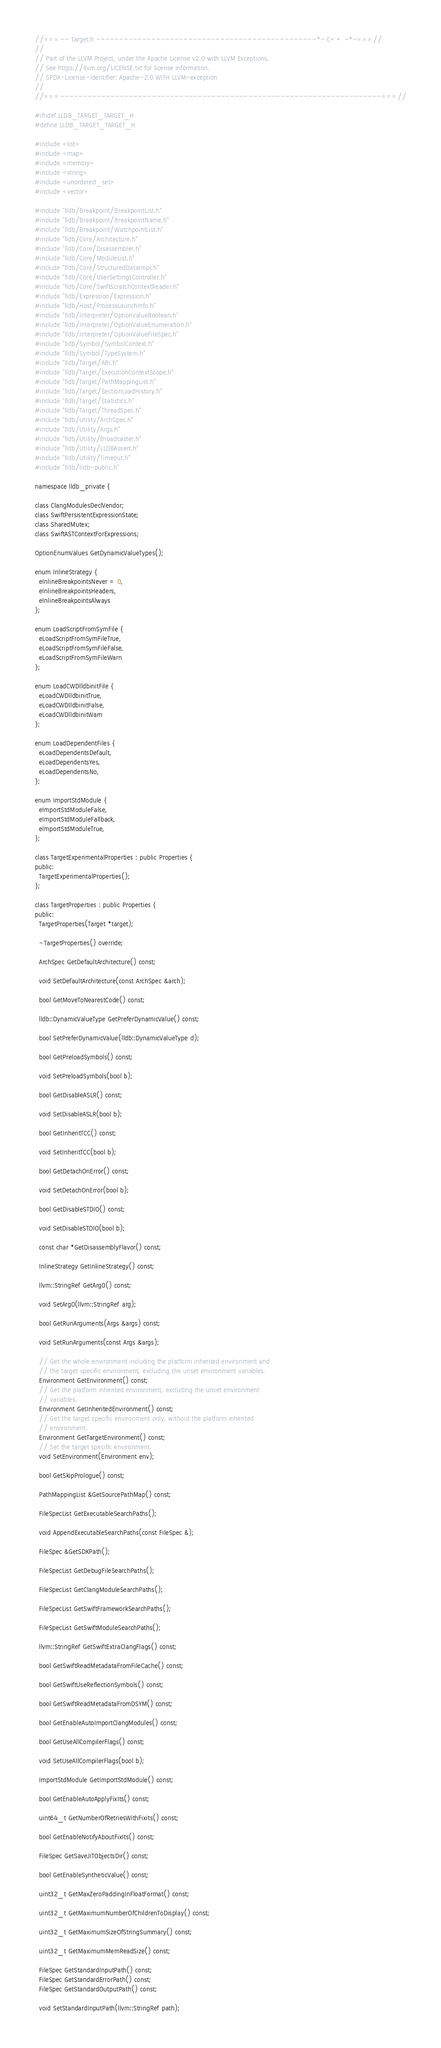<code> <loc_0><loc_0><loc_500><loc_500><_C_>//===-- Target.h ------------------------------------------------*- C++ -*-===//
//
// Part of the LLVM Project, under the Apache License v2.0 with LLVM Exceptions.
// See https://llvm.org/LICENSE.txt for license information.
// SPDX-License-Identifier: Apache-2.0 WITH LLVM-exception
//
//===----------------------------------------------------------------------===//

#ifndef LLDB_TARGET_TARGET_H
#define LLDB_TARGET_TARGET_H

#include <list>
#include <map>
#include <memory>
#include <string>
#include <unordered_set>
#include <vector>

#include "lldb/Breakpoint/BreakpointList.h"
#include "lldb/Breakpoint/BreakpointName.h"
#include "lldb/Breakpoint/WatchpointList.h"
#include "lldb/Core/Architecture.h"
#include "lldb/Core/Disassembler.h"
#include "lldb/Core/ModuleList.h"
#include "lldb/Core/StructuredDataImpl.h"
#include "lldb/Core/UserSettingsController.h"
#include "lldb/Core/SwiftScratchContextReader.h"
#include "lldb/Expression/Expression.h"
#include "lldb/Host/ProcessLaunchInfo.h"
#include "lldb/Interpreter/OptionValueBoolean.h"
#include "lldb/Interpreter/OptionValueEnumeration.h"
#include "lldb/Interpreter/OptionValueFileSpec.h"
#include "lldb/Symbol/SymbolContext.h"
#include "lldb/Symbol/TypeSystem.h"
#include "lldb/Target/ABI.h"
#include "lldb/Target/ExecutionContextScope.h"
#include "lldb/Target/PathMappingList.h"
#include "lldb/Target/SectionLoadHistory.h"
#include "lldb/Target/Statistics.h"
#include "lldb/Target/ThreadSpec.h"
#include "lldb/Utility/ArchSpec.h"
#include "lldb/Utility/Args.h"
#include "lldb/Utility/Broadcaster.h"
#include "lldb/Utility/LLDBAssert.h"
#include "lldb/Utility/Timeout.h"
#include "lldb/lldb-public.h"

namespace lldb_private {

class ClangModulesDeclVendor;
class SwiftPersistentExpressionState;
class SharedMutex;
class SwiftASTContextForExpressions;

OptionEnumValues GetDynamicValueTypes();

enum InlineStrategy {
  eInlineBreakpointsNever = 0,
  eInlineBreakpointsHeaders,
  eInlineBreakpointsAlways
};

enum LoadScriptFromSymFile {
  eLoadScriptFromSymFileTrue,
  eLoadScriptFromSymFileFalse,
  eLoadScriptFromSymFileWarn
};

enum LoadCWDlldbinitFile {
  eLoadCWDlldbinitTrue,
  eLoadCWDlldbinitFalse,
  eLoadCWDlldbinitWarn
};

enum LoadDependentFiles {
  eLoadDependentsDefault,
  eLoadDependentsYes,
  eLoadDependentsNo,
};

enum ImportStdModule {
  eImportStdModuleFalse,
  eImportStdModuleFallback,
  eImportStdModuleTrue,
};

class TargetExperimentalProperties : public Properties {
public:
  TargetExperimentalProperties();
};

class TargetProperties : public Properties {
public:
  TargetProperties(Target *target);

  ~TargetProperties() override;

  ArchSpec GetDefaultArchitecture() const;

  void SetDefaultArchitecture(const ArchSpec &arch);

  bool GetMoveToNearestCode() const;

  lldb::DynamicValueType GetPreferDynamicValue() const;

  bool SetPreferDynamicValue(lldb::DynamicValueType d);

  bool GetPreloadSymbols() const;

  void SetPreloadSymbols(bool b);

  bool GetDisableASLR() const;

  void SetDisableASLR(bool b);

  bool GetInheritTCC() const;

  void SetInheritTCC(bool b);

  bool GetDetachOnError() const;

  void SetDetachOnError(bool b);

  bool GetDisableSTDIO() const;

  void SetDisableSTDIO(bool b);

  const char *GetDisassemblyFlavor() const;

  InlineStrategy GetInlineStrategy() const;

  llvm::StringRef GetArg0() const;

  void SetArg0(llvm::StringRef arg);

  bool GetRunArguments(Args &args) const;

  void SetRunArguments(const Args &args);

  // Get the whole environment including the platform inherited environment and
  // the target specific environment, excluding the unset environment variables.
  Environment GetEnvironment() const;
  // Get the platform inherited environment, excluding the unset environment
  // variables.
  Environment GetInheritedEnvironment() const;
  // Get the target specific environment only, without the platform inherited
  // environment.
  Environment GetTargetEnvironment() const;
  // Set the target specific environment.
  void SetEnvironment(Environment env);

  bool GetSkipPrologue() const;

  PathMappingList &GetSourcePathMap() const;

  FileSpecList GetExecutableSearchPaths();

  void AppendExecutableSearchPaths(const FileSpec &);

  FileSpec &GetSDKPath();

  FileSpecList GetDebugFileSearchPaths();

  FileSpecList GetClangModuleSearchPaths();

  FileSpecList GetSwiftFrameworkSearchPaths();

  FileSpecList GetSwiftModuleSearchPaths();

  llvm::StringRef GetSwiftExtraClangFlags() const;

  bool GetSwiftReadMetadataFromFileCache() const;

  bool GetSwiftUseReflectionSymbols() const;
  
  bool GetSwiftReadMetadataFromDSYM() const;

  bool GetEnableAutoImportClangModules() const;

  bool GetUseAllCompilerFlags() const;

  void SetUseAllCompilerFlags(bool b);

  ImportStdModule GetImportStdModule() const;

  bool GetEnableAutoApplyFixIts() const;

  uint64_t GetNumberOfRetriesWithFixits() const;

  bool GetEnableNotifyAboutFixIts() const;

  FileSpec GetSaveJITObjectsDir() const;
  
  bool GetEnableSyntheticValue() const;

  uint32_t GetMaxZeroPaddingInFloatFormat() const;

  uint32_t GetMaximumNumberOfChildrenToDisplay() const;

  uint32_t GetMaximumSizeOfStringSummary() const;

  uint32_t GetMaximumMemReadSize() const;

  FileSpec GetStandardInputPath() const;
  FileSpec GetStandardErrorPath() const;
  FileSpec GetStandardOutputPath() const;

  void SetStandardInputPath(llvm::StringRef path);</code> 